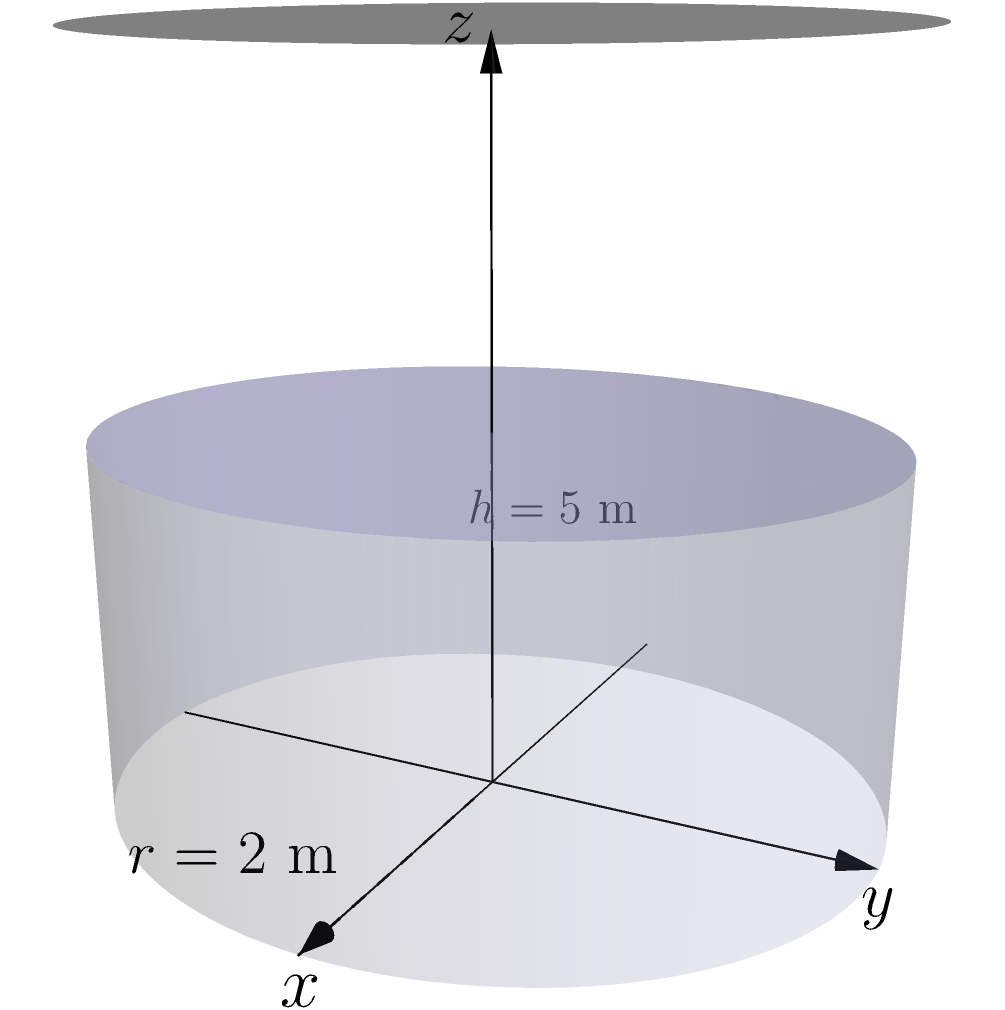As a farmer in the Umvoti agricultural community, you need to calculate the volume of a cylindrical water tank for irrigation. The tank has a height of 5 meters and a radius of 2 meters, as shown in the diagram. What is the volume of this tank in cubic meters? To calculate the volume of a cylindrical tank, we use the formula:

$$V = \pi r^2 h$$

Where:
$V$ = volume
$\pi$ = pi (approximately 3.14159)
$r$ = radius of the base
$h$ = height of the cylinder

Given:
$r = 2$ meters
$h = 5$ meters

Let's substitute these values into the formula:

$$V = \pi (2)^2 (5)$$

$$V = \pi (4) (5)$$

$$V = 20\pi$$

Calculating this:

$$V \approx 20 \times 3.14159$$

$$V \approx 62.8318 \text{ cubic meters}$$

Rounding to two decimal places:

$$V \approx 62.83 \text{ cubic meters}$$
Answer: $62.83 \text{ m}^3$ 